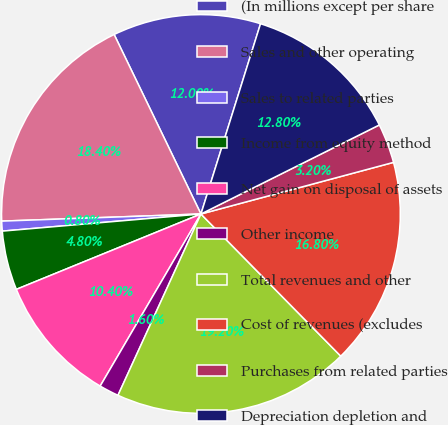Convert chart. <chart><loc_0><loc_0><loc_500><loc_500><pie_chart><fcel>(In millions except per share<fcel>Sales and other operating<fcel>Sales to related parties<fcel>Income from equity method<fcel>Net gain on disposal of assets<fcel>Other income<fcel>Total revenues and other<fcel>Cost of revenues (excludes<fcel>Purchases from related parties<fcel>Depreciation depletion and<nl><fcel>12.0%<fcel>18.4%<fcel>0.8%<fcel>4.8%<fcel>10.4%<fcel>1.6%<fcel>19.2%<fcel>16.8%<fcel>3.2%<fcel>12.8%<nl></chart> 